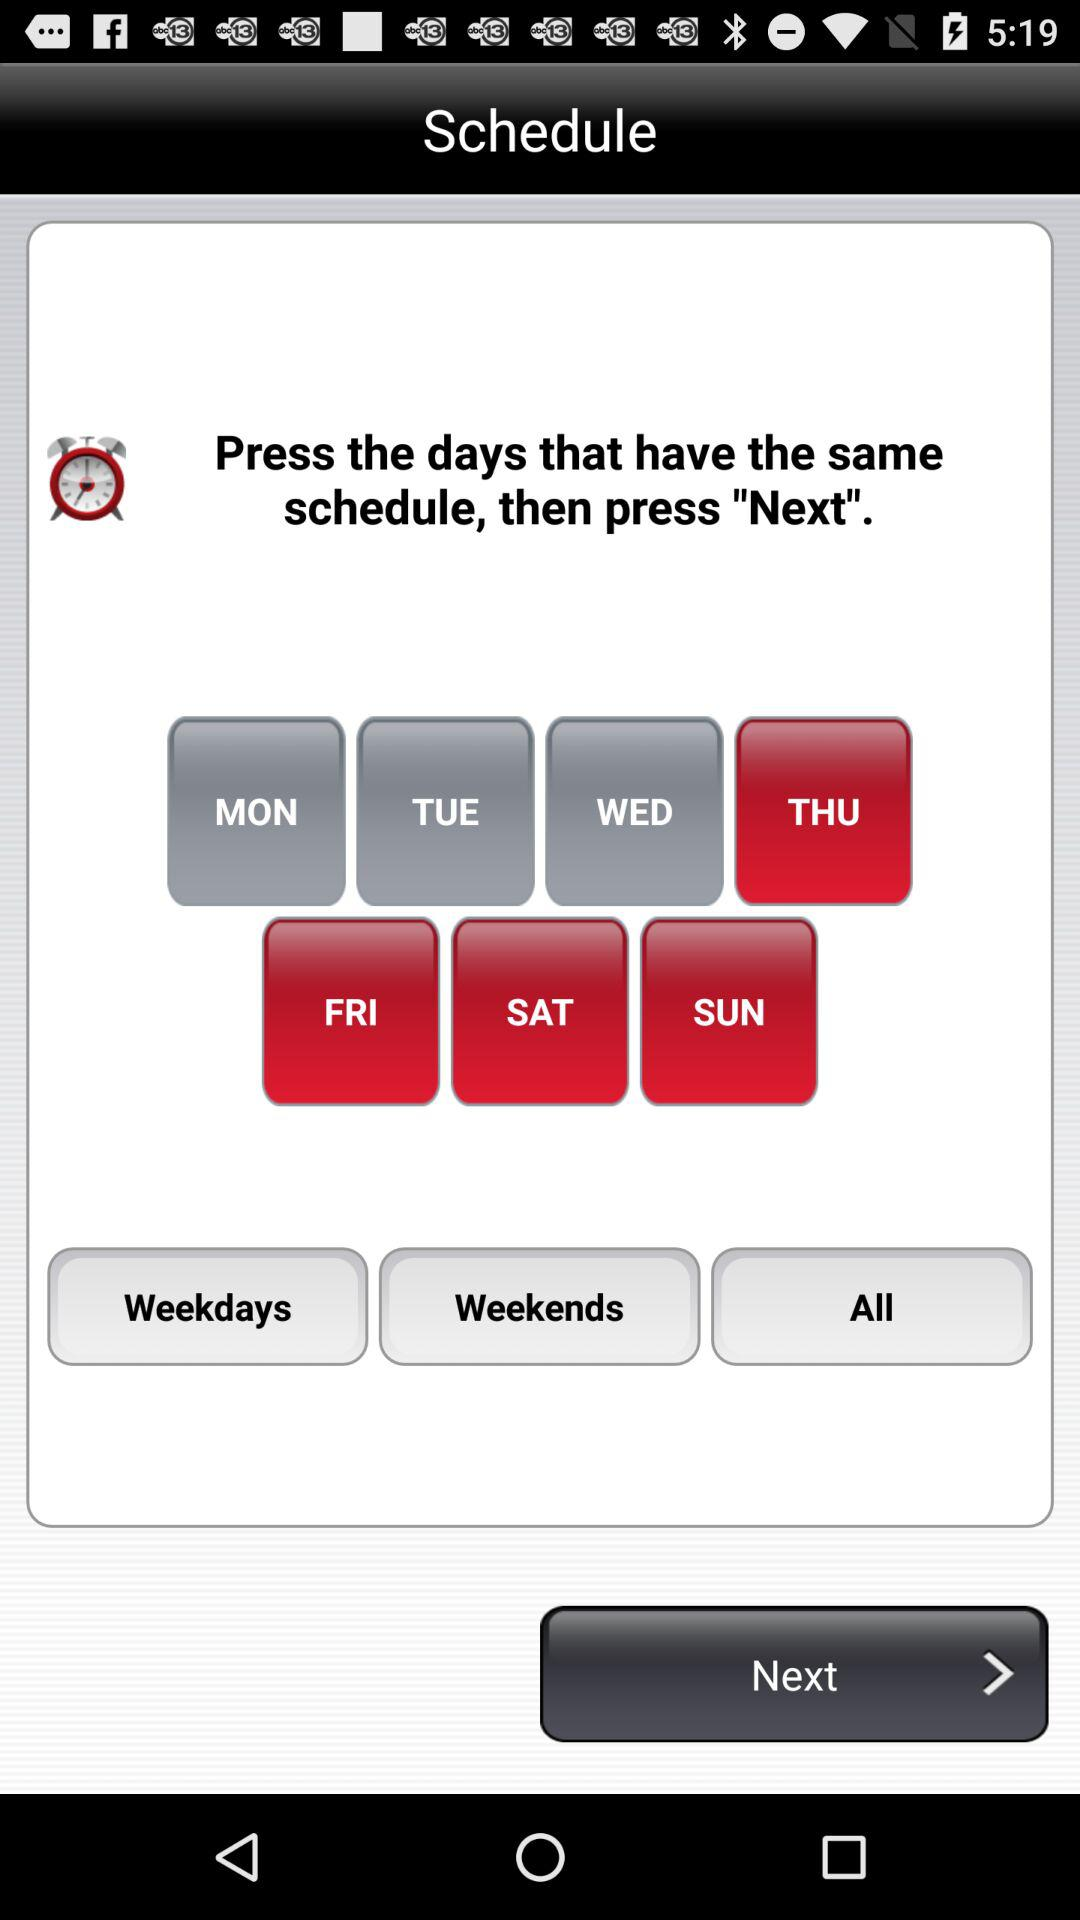How many days are not selected?
Answer the question using a single word or phrase. 3 